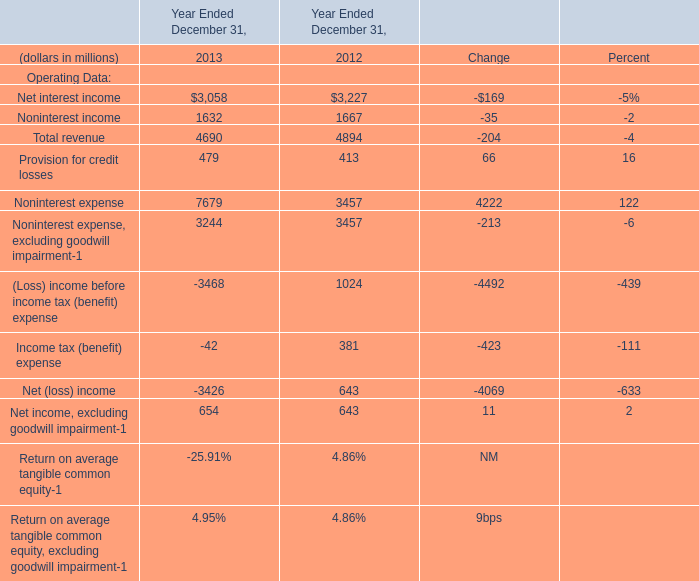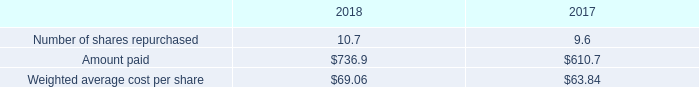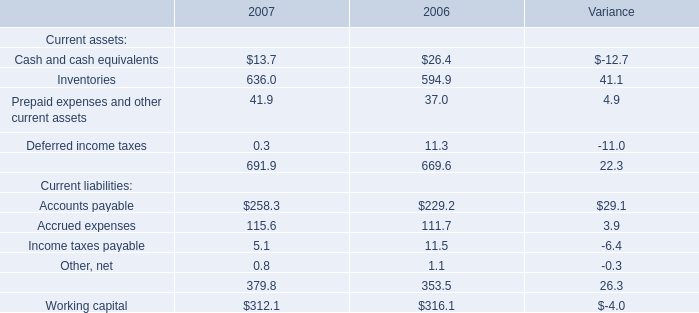between 2018 and 2017 what was the percent change in the weighted average cost per share 
Computations: ((69.06 - 63.84) / 63.84)
Answer: 0.08177. 